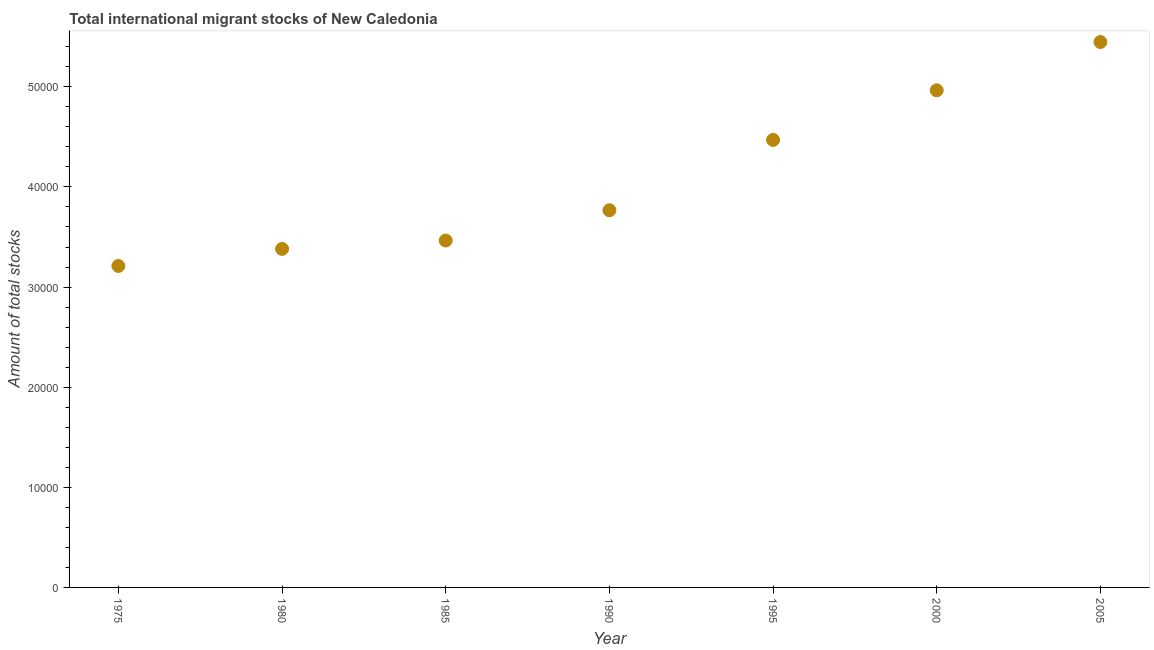What is the total number of international migrant stock in 1985?
Your answer should be compact. 3.46e+04. Across all years, what is the maximum total number of international migrant stock?
Make the answer very short. 5.45e+04. Across all years, what is the minimum total number of international migrant stock?
Offer a very short reply. 3.21e+04. In which year was the total number of international migrant stock minimum?
Your answer should be very brief. 1975. What is the sum of the total number of international migrant stock?
Your answer should be very brief. 2.87e+05. What is the difference between the total number of international migrant stock in 1975 and 1990?
Offer a terse response. -5565. What is the average total number of international migrant stock per year?
Your answer should be compact. 4.10e+04. What is the median total number of international migrant stock?
Give a very brief answer. 3.77e+04. In how many years, is the total number of international migrant stock greater than 28000 ?
Your answer should be very brief. 7. Do a majority of the years between 1975 and 2000 (inclusive) have total number of international migrant stock greater than 48000 ?
Provide a succinct answer. No. What is the ratio of the total number of international migrant stock in 1975 to that in 2005?
Make the answer very short. 0.59. Is the difference between the total number of international migrant stock in 1980 and 2005 greater than the difference between any two years?
Your answer should be very brief. No. What is the difference between the highest and the second highest total number of international migrant stock?
Your answer should be very brief. 4824. Is the sum of the total number of international migrant stock in 1990 and 2000 greater than the maximum total number of international migrant stock across all years?
Keep it short and to the point. Yes. What is the difference between the highest and the lowest total number of international migrant stock?
Provide a short and direct response. 2.24e+04. How many years are there in the graph?
Make the answer very short. 7. What is the difference between two consecutive major ticks on the Y-axis?
Your answer should be very brief. 10000. Are the values on the major ticks of Y-axis written in scientific E-notation?
Offer a very short reply. No. Does the graph contain any zero values?
Keep it short and to the point. No. What is the title of the graph?
Your response must be concise. Total international migrant stocks of New Caledonia. What is the label or title of the X-axis?
Ensure brevity in your answer.  Year. What is the label or title of the Y-axis?
Your response must be concise. Amount of total stocks. What is the Amount of total stocks in 1975?
Give a very brief answer. 3.21e+04. What is the Amount of total stocks in 1980?
Your response must be concise. 3.38e+04. What is the Amount of total stocks in 1985?
Your answer should be very brief. 3.46e+04. What is the Amount of total stocks in 1990?
Provide a short and direct response. 3.77e+04. What is the Amount of total stocks in 1995?
Make the answer very short. 4.47e+04. What is the Amount of total stocks in 2000?
Your response must be concise. 4.97e+04. What is the Amount of total stocks in 2005?
Give a very brief answer. 5.45e+04. What is the difference between the Amount of total stocks in 1975 and 1980?
Your answer should be compact. -1703. What is the difference between the Amount of total stocks in 1975 and 1985?
Your response must be concise. -2540. What is the difference between the Amount of total stocks in 1975 and 1990?
Your response must be concise. -5565. What is the difference between the Amount of total stocks in 1975 and 1995?
Your answer should be compact. -1.26e+04. What is the difference between the Amount of total stocks in 1975 and 2000?
Offer a very short reply. -1.75e+04. What is the difference between the Amount of total stocks in 1975 and 2005?
Give a very brief answer. -2.24e+04. What is the difference between the Amount of total stocks in 1980 and 1985?
Give a very brief answer. -837. What is the difference between the Amount of total stocks in 1980 and 1990?
Provide a succinct answer. -3862. What is the difference between the Amount of total stocks in 1980 and 1995?
Give a very brief answer. -1.09e+04. What is the difference between the Amount of total stocks in 1980 and 2000?
Provide a succinct answer. -1.58e+04. What is the difference between the Amount of total stocks in 1980 and 2005?
Your answer should be very brief. -2.07e+04. What is the difference between the Amount of total stocks in 1985 and 1990?
Your answer should be very brief. -3025. What is the difference between the Amount of total stocks in 1985 and 1995?
Provide a short and direct response. -1.00e+04. What is the difference between the Amount of total stocks in 1985 and 2000?
Provide a short and direct response. -1.50e+04. What is the difference between the Amount of total stocks in 1985 and 2005?
Provide a short and direct response. -1.98e+04. What is the difference between the Amount of total stocks in 1990 and 1995?
Your answer should be compact. -7024. What is the difference between the Amount of total stocks in 1990 and 2000?
Make the answer very short. -1.20e+04. What is the difference between the Amount of total stocks in 1990 and 2005?
Give a very brief answer. -1.68e+04. What is the difference between the Amount of total stocks in 1995 and 2000?
Your response must be concise. -4954. What is the difference between the Amount of total stocks in 1995 and 2005?
Provide a succinct answer. -9778. What is the difference between the Amount of total stocks in 2000 and 2005?
Make the answer very short. -4824. What is the ratio of the Amount of total stocks in 1975 to that in 1980?
Offer a terse response. 0.95. What is the ratio of the Amount of total stocks in 1975 to that in 1985?
Offer a terse response. 0.93. What is the ratio of the Amount of total stocks in 1975 to that in 1990?
Keep it short and to the point. 0.85. What is the ratio of the Amount of total stocks in 1975 to that in 1995?
Give a very brief answer. 0.72. What is the ratio of the Amount of total stocks in 1975 to that in 2000?
Your answer should be very brief. 0.65. What is the ratio of the Amount of total stocks in 1975 to that in 2005?
Make the answer very short. 0.59. What is the ratio of the Amount of total stocks in 1980 to that in 1990?
Offer a very short reply. 0.9. What is the ratio of the Amount of total stocks in 1980 to that in 1995?
Your answer should be very brief. 0.76. What is the ratio of the Amount of total stocks in 1980 to that in 2000?
Your response must be concise. 0.68. What is the ratio of the Amount of total stocks in 1980 to that in 2005?
Ensure brevity in your answer.  0.62. What is the ratio of the Amount of total stocks in 1985 to that in 1990?
Provide a succinct answer. 0.92. What is the ratio of the Amount of total stocks in 1985 to that in 1995?
Provide a succinct answer. 0.78. What is the ratio of the Amount of total stocks in 1985 to that in 2000?
Provide a short and direct response. 0.7. What is the ratio of the Amount of total stocks in 1985 to that in 2005?
Your answer should be very brief. 0.64. What is the ratio of the Amount of total stocks in 1990 to that in 1995?
Offer a very short reply. 0.84. What is the ratio of the Amount of total stocks in 1990 to that in 2000?
Offer a terse response. 0.76. What is the ratio of the Amount of total stocks in 1990 to that in 2005?
Ensure brevity in your answer.  0.69. What is the ratio of the Amount of total stocks in 1995 to that in 2000?
Your answer should be very brief. 0.9. What is the ratio of the Amount of total stocks in 1995 to that in 2005?
Give a very brief answer. 0.82. What is the ratio of the Amount of total stocks in 2000 to that in 2005?
Give a very brief answer. 0.91. 